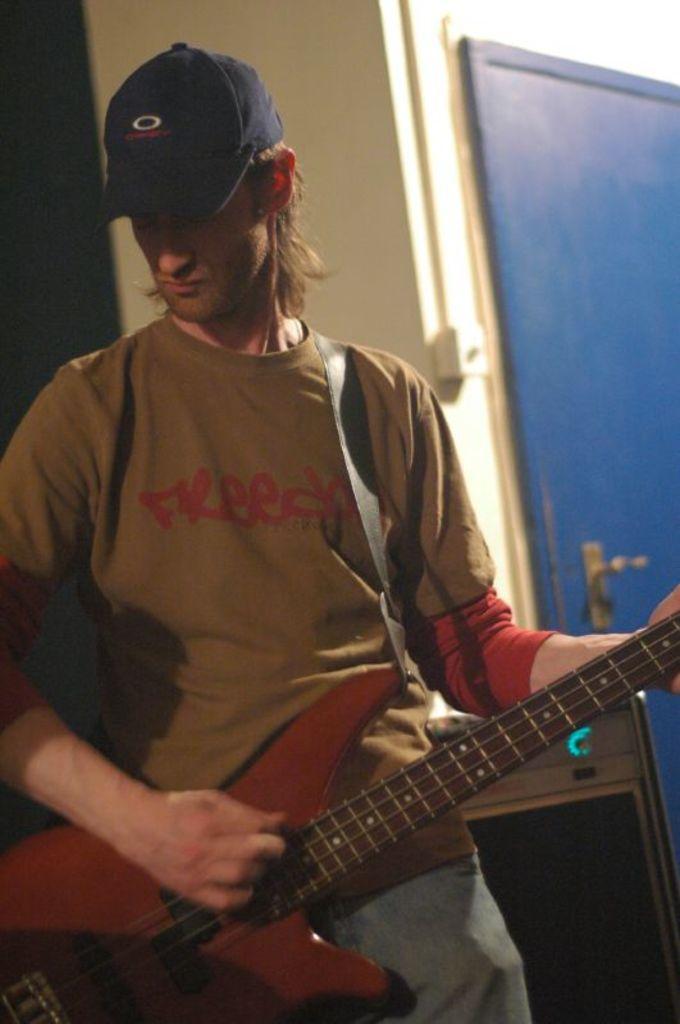In one or two sentences, can you explain what this image depicts? On the background we can see a wall and a door in blue colour. Here we can see one man standing and playing guitar. He wore a cap. 